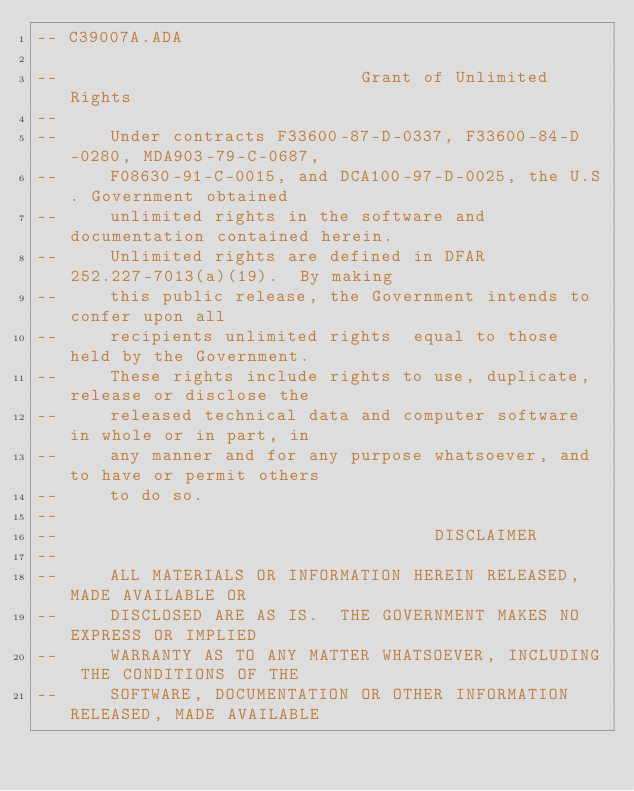Convert code to text. <code><loc_0><loc_0><loc_500><loc_500><_Ada_>-- C39007A.ADA

--                             Grant of Unlimited Rights
--
--     Under contracts F33600-87-D-0337, F33600-84-D-0280, MDA903-79-C-0687,
--     F08630-91-C-0015, and DCA100-97-D-0025, the U.S. Government obtained 
--     unlimited rights in the software and documentation contained herein.
--     Unlimited rights are defined in DFAR 252.227-7013(a)(19).  By making 
--     this public release, the Government intends to confer upon all 
--     recipients unlimited rights  equal to those held by the Government.  
--     These rights include rights to use, duplicate, release or disclose the 
--     released technical data and computer software in whole or in part, in 
--     any manner and for any purpose whatsoever, and to have or permit others 
--     to do so.
--
--                                    DISCLAIMER
--
--     ALL MATERIALS OR INFORMATION HEREIN RELEASED, MADE AVAILABLE OR
--     DISCLOSED ARE AS IS.  THE GOVERNMENT MAKES NO EXPRESS OR IMPLIED 
--     WARRANTY AS TO ANY MATTER WHATSOEVER, INCLUDING THE CONDITIONS OF THE
--     SOFTWARE, DOCUMENTATION OR OTHER INFORMATION RELEASED, MADE AVAILABLE </code> 